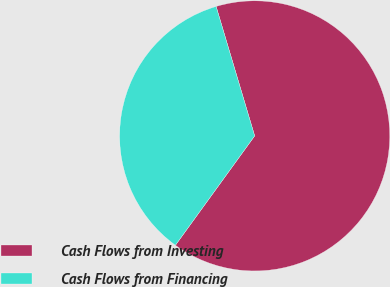Convert chart. <chart><loc_0><loc_0><loc_500><loc_500><pie_chart><fcel>Cash Flows from Investing<fcel>Cash Flows from Financing<nl><fcel>64.59%<fcel>35.41%<nl></chart> 